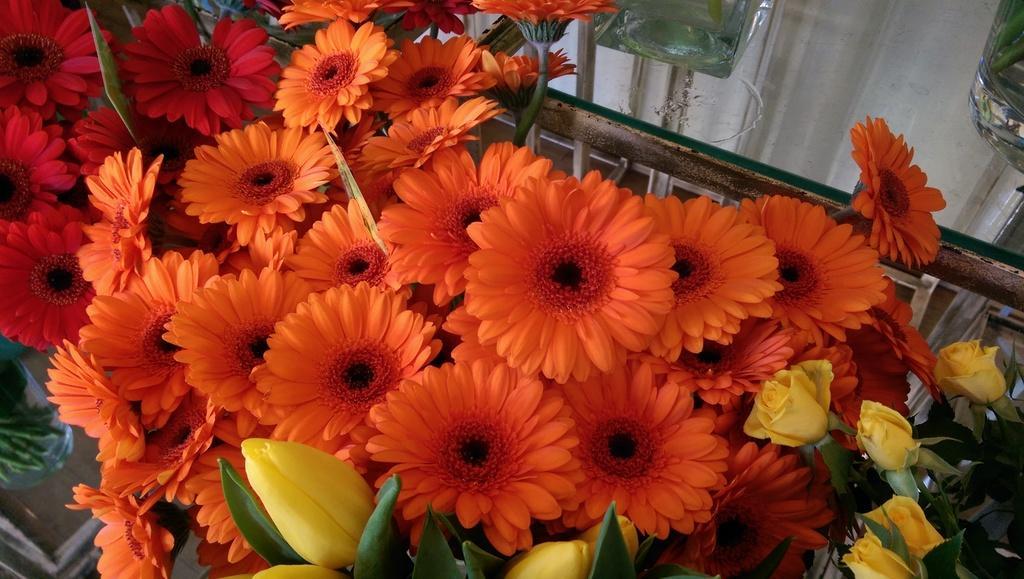How would you summarize this image in a sentence or two? In this image, we can see some flowers and glass objects. We can also see the background. 